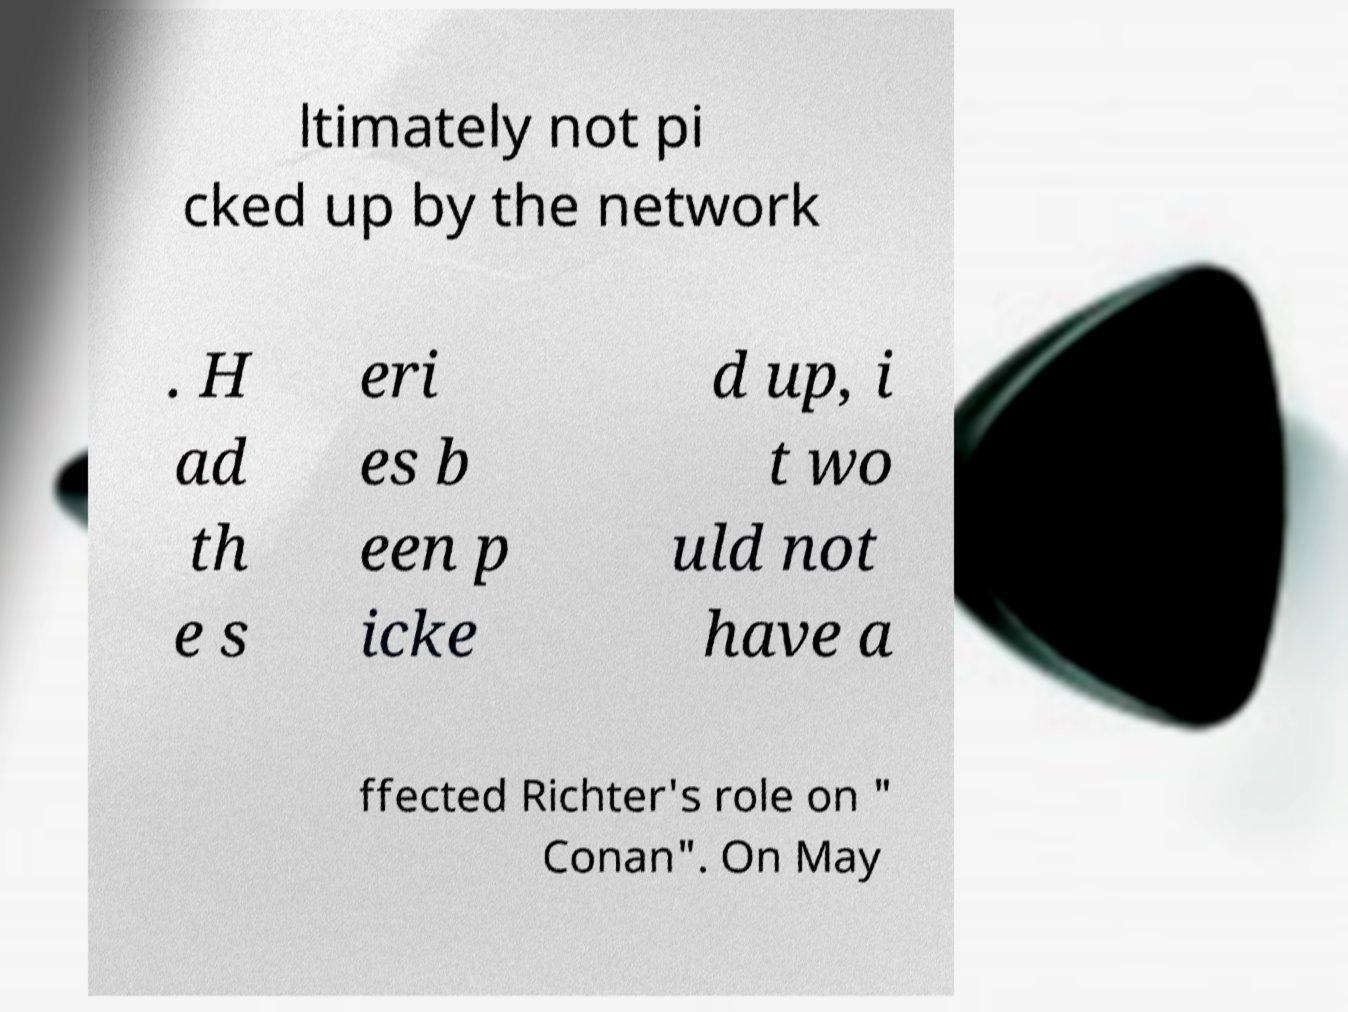For documentation purposes, I need the text within this image transcribed. Could you provide that? ltimately not pi cked up by the network . H ad th e s eri es b een p icke d up, i t wo uld not have a ffected Richter's role on " Conan". On May 